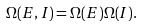Convert formula to latex. <formula><loc_0><loc_0><loc_500><loc_500>\Omega ( E , I ) = \Omega ( E ) \Omega ( I ) .</formula> 